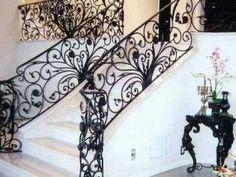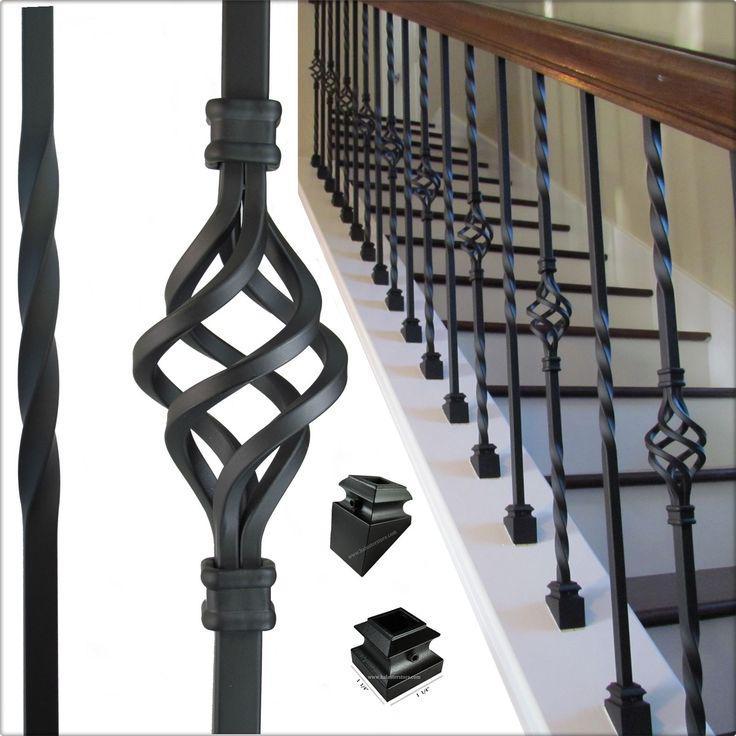The first image is the image on the left, the second image is the image on the right. Analyze the images presented: Is the assertion "The left image shows a staircase with an ornate black wrought iron rail and a corner post featuring wrought iron curved around to form a cylinder shape." valid? Answer yes or no. Yes. 